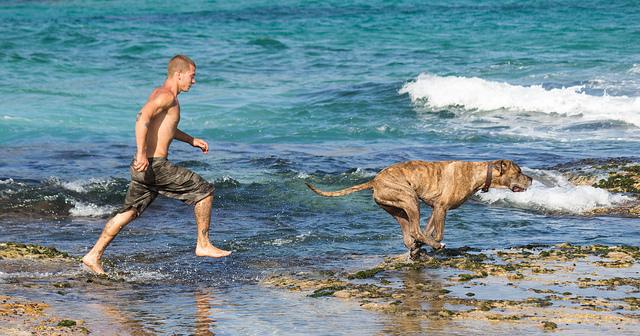Are the dog and the man together?
Answer briefly. Yes. Does the dog like water?
Answer briefly. Yes. Is the dog wearing a collar?
Concise answer only. Yes. 